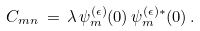Convert formula to latex. <formula><loc_0><loc_0><loc_500><loc_500>C _ { m n } \, = \, \lambda \, \psi _ { m } ^ { ( \epsilon ) } ( 0 ) \, \psi _ { m } ^ { ( \epsilon ) * } ( 0 ) \, .</formula> 